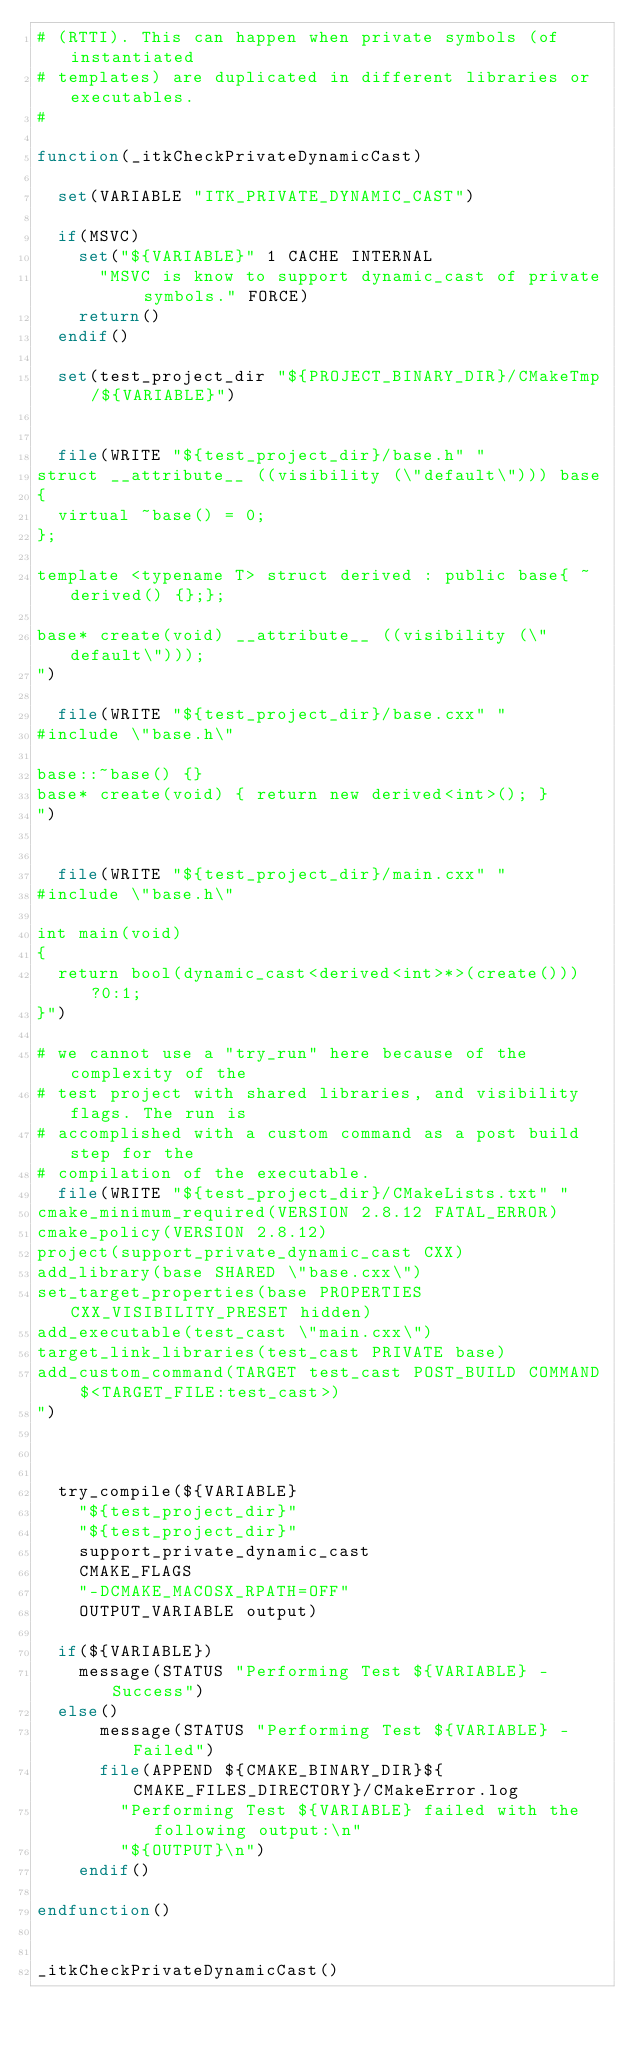<code> <loc_0><loc_0><loc_500><loc_500><_CMake_># (RTTI). This can happen when private symbols (of instantiated
# templates) are duplicated in different libraries or executables.
#

function(_itkCheckPrivateDynamicCast)

  set(VARIABLE "ITK_PRIVATE_DYNAMIC_CAST")

  if(MSVC)
    set("${VARIABLE}" 1 CACHE INTERNAL
      "MSVC is know to support dynamic_cast of private symbols." FORCE)
    return()
  endif()

  set(test_project_dir "${PROJECT_BINARY_DIR}/CMakeTmp/${VARIABLE}")


  file(WRITE "${test_project_dir}/base.h" "
struct __attribute__ ((visibility (\"default\"))) base
{
  virtual ~base() = 0;
};

template <typename T> struct derived : public base{ ~derived() {};};

base* create(void) __attribute__ ((visibility (\"default\")));
")

  file(WRITE "${test_project_dir}/base.cxx" "
#include \"base.h\"

base::~base() {}
base* create(void) { return new derived<int>(); }
")


  file(WRITE "${test_project_dir}/main.cxx" "
#include \"base.h\"

int main(void)
{
  return bool(dynamic_cast<derived<int>*>(create()))?0:1;
}")

# we cannot use a "try_run" here because of the complexity of the
# test project with shared libraries, and visibility flags. The run is
# accomplished with a custom command as a post build step for the
# compilation of the executable.
  file(WRITE "${test_project_dir}/CMakeLists.txt" "
cmake_minimum_required(VERSION 2.8.12 FATAL_ERROR)
cmake_policy(VERSION 2.8.12)
project(support_private_dynamic_cast CXX)
add_library(base SHARED \"base.cxx\")
set_target_properties(base PROPERTIES CXX_VISIBILITY_PRESET hidden)
add_executable(test_cast \"main.cxx\")
target_link_libraries(test_cast PRIVATE base)
add_custom_command(TARGET test_cast POST_BUILD COMMAND $<TARGET_FILE:test_cast>)
")



  try_compile(${VARIABLE}
    "${test_project_dir}"
    "${test_project_dir}"
    support_private_dynamic_cast
    CMAKE_FLAGS
    "-DCMAKE_MACOSX_RPATH=OFF"
    OUTPUT_VARIABLE output)

  if(${VARIABLE})
    message(STATUS "Performing Test ${VARIABLE} - Success")
  else()
      message(STATUS "Performing Test ${VARIABLE} - Failed")
      file(APPEND ${CMAKE_BINARY_DIR}${CMAKE_FILES_DIRECTORY}/CMakeError.log
        "Performing Test ${VARIABLE} failed with the following output:\n"
        "${OUTPUT}\n")
    endif()

endfunction()


_itkCheckPrivateDynamicCast()
</code> 